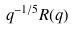Convert formula to latex. <formula><loc_0><loc_0><loc_500><loc_500>q ^ { - 1 / 5 } R ( q )</formula> 